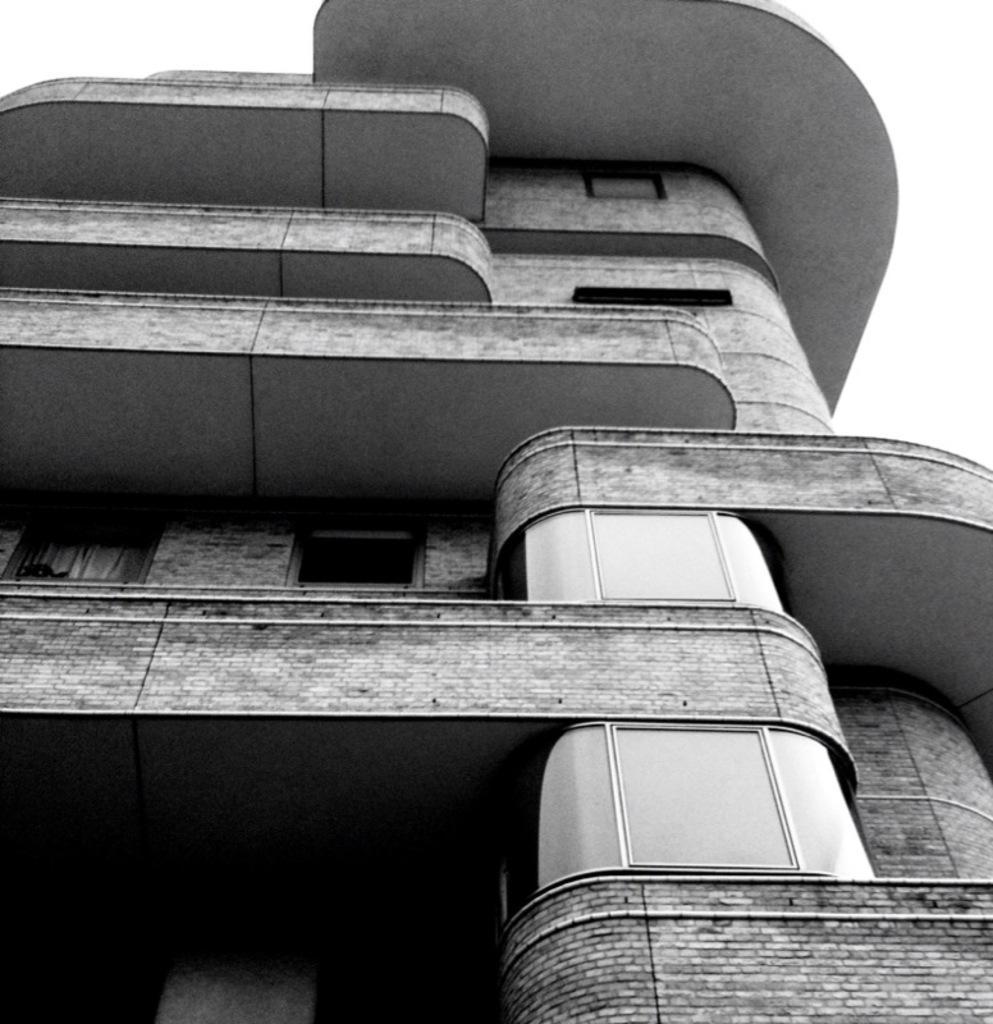In one or two sentences, can you explain what this image depicts? This is a black and white image and here we can see a building. 